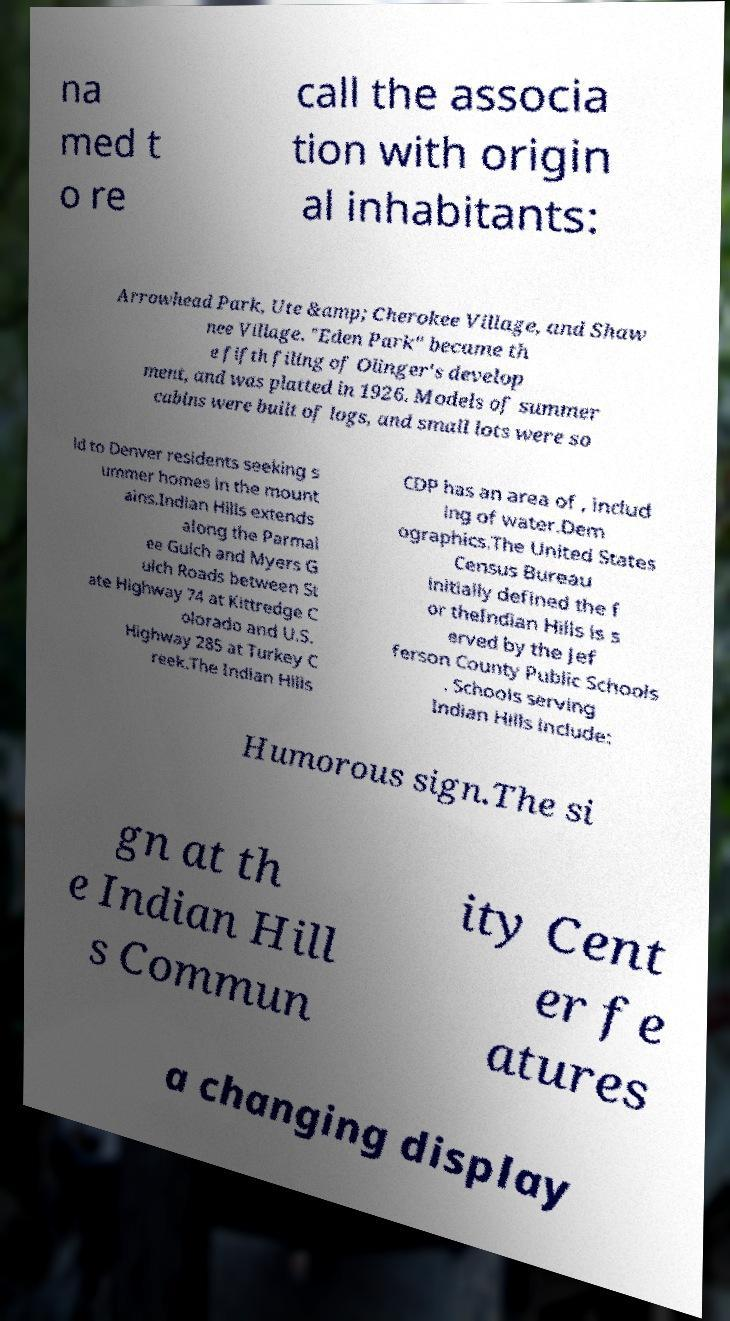I need the written content from this picture converted into text. Can you do that? na med t o re call the associa tion with origin al inhabitants: Arrowhead Park, Ute &amp; Cherokee Village, and Shaw nee Village. "Eden Park" became th e fifth filing of Olinger's develop ment, and was platted in 1926. Models of summer cabins were built of logs, and small lots were so ld to Denver residents seeking s ummer homes in the mount ains.Indian Hills extends along the Parmal ee Gulch and Myers G ulch Roads between St ate Highway 74 at Kittredge C olorado and U.S. Highway 285 at Turkey C reek.The Indian Hills CDP has an area of , includ ing of water.Dem ographics.The United States Census Bureau initially defined the f or theIndian Hills is s erved by the Jef ferson County Public Schools . Schools serving Indian Hills include: Humorous sign.The si gn at th e Indian Hill s Commun ity Cent er fe atures a changing display 